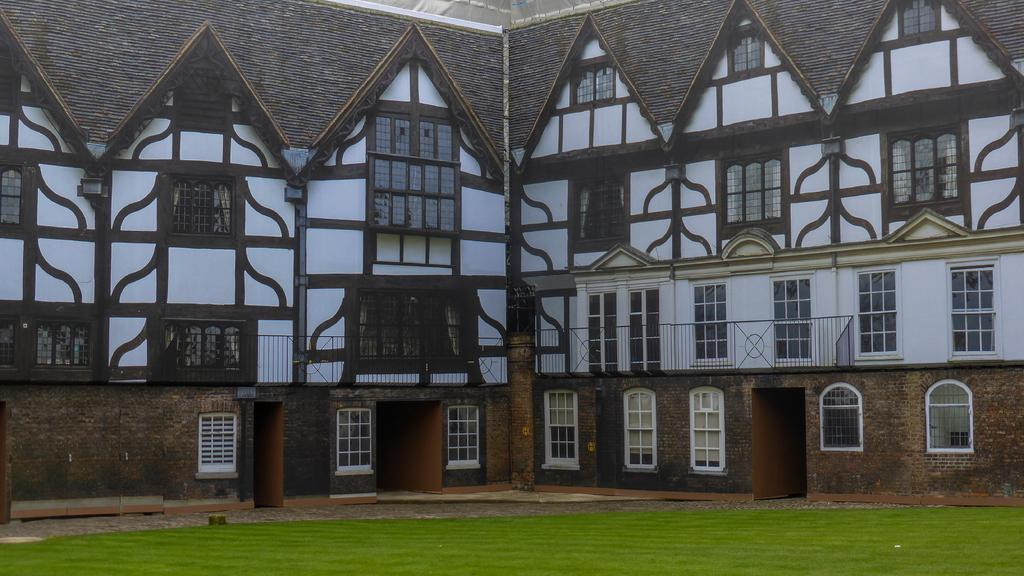What type of structure is present in the image? There is a building in the image. What colors can be seen on the building? The building has brown and white colors. What type of material is used for the windows on the building? There are glass windows on the building. What color is the grass in the image? The grass in the image is green. How many times has the building been twisted in the image? The building has not been twisted in the image; it is a solid structure with no visible distortion. 